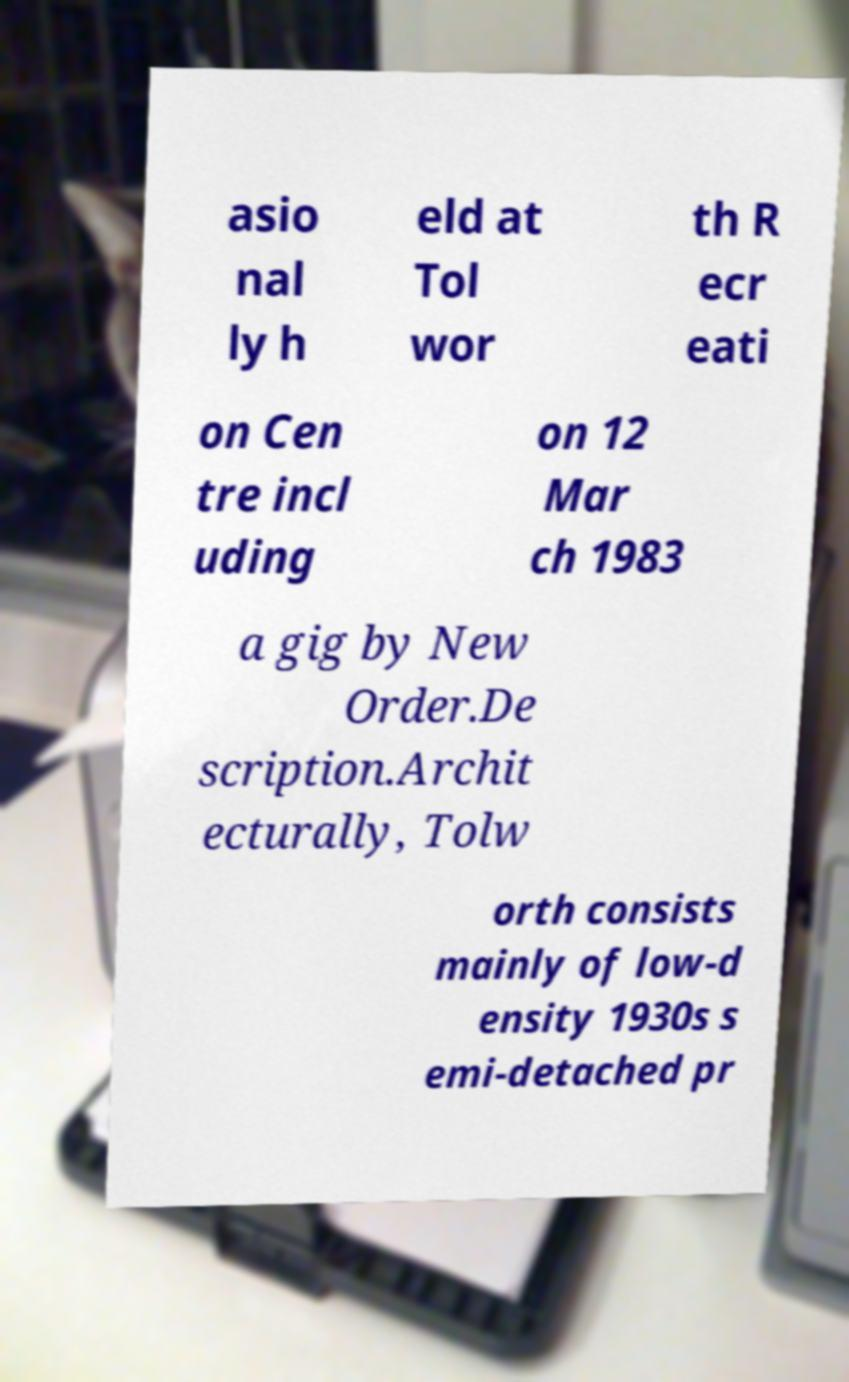Could you assist in decoding the text presented in this image and type it out clearly? asio nal ly h eld at Tol wor th R ecr eati on Cen tre incl uding on 12 Mar ch 1983 a gig by New Order.De scription.Archit ecturally, Tolw orth consists mainly of low-d ensity 1930s s emi-detached pr 